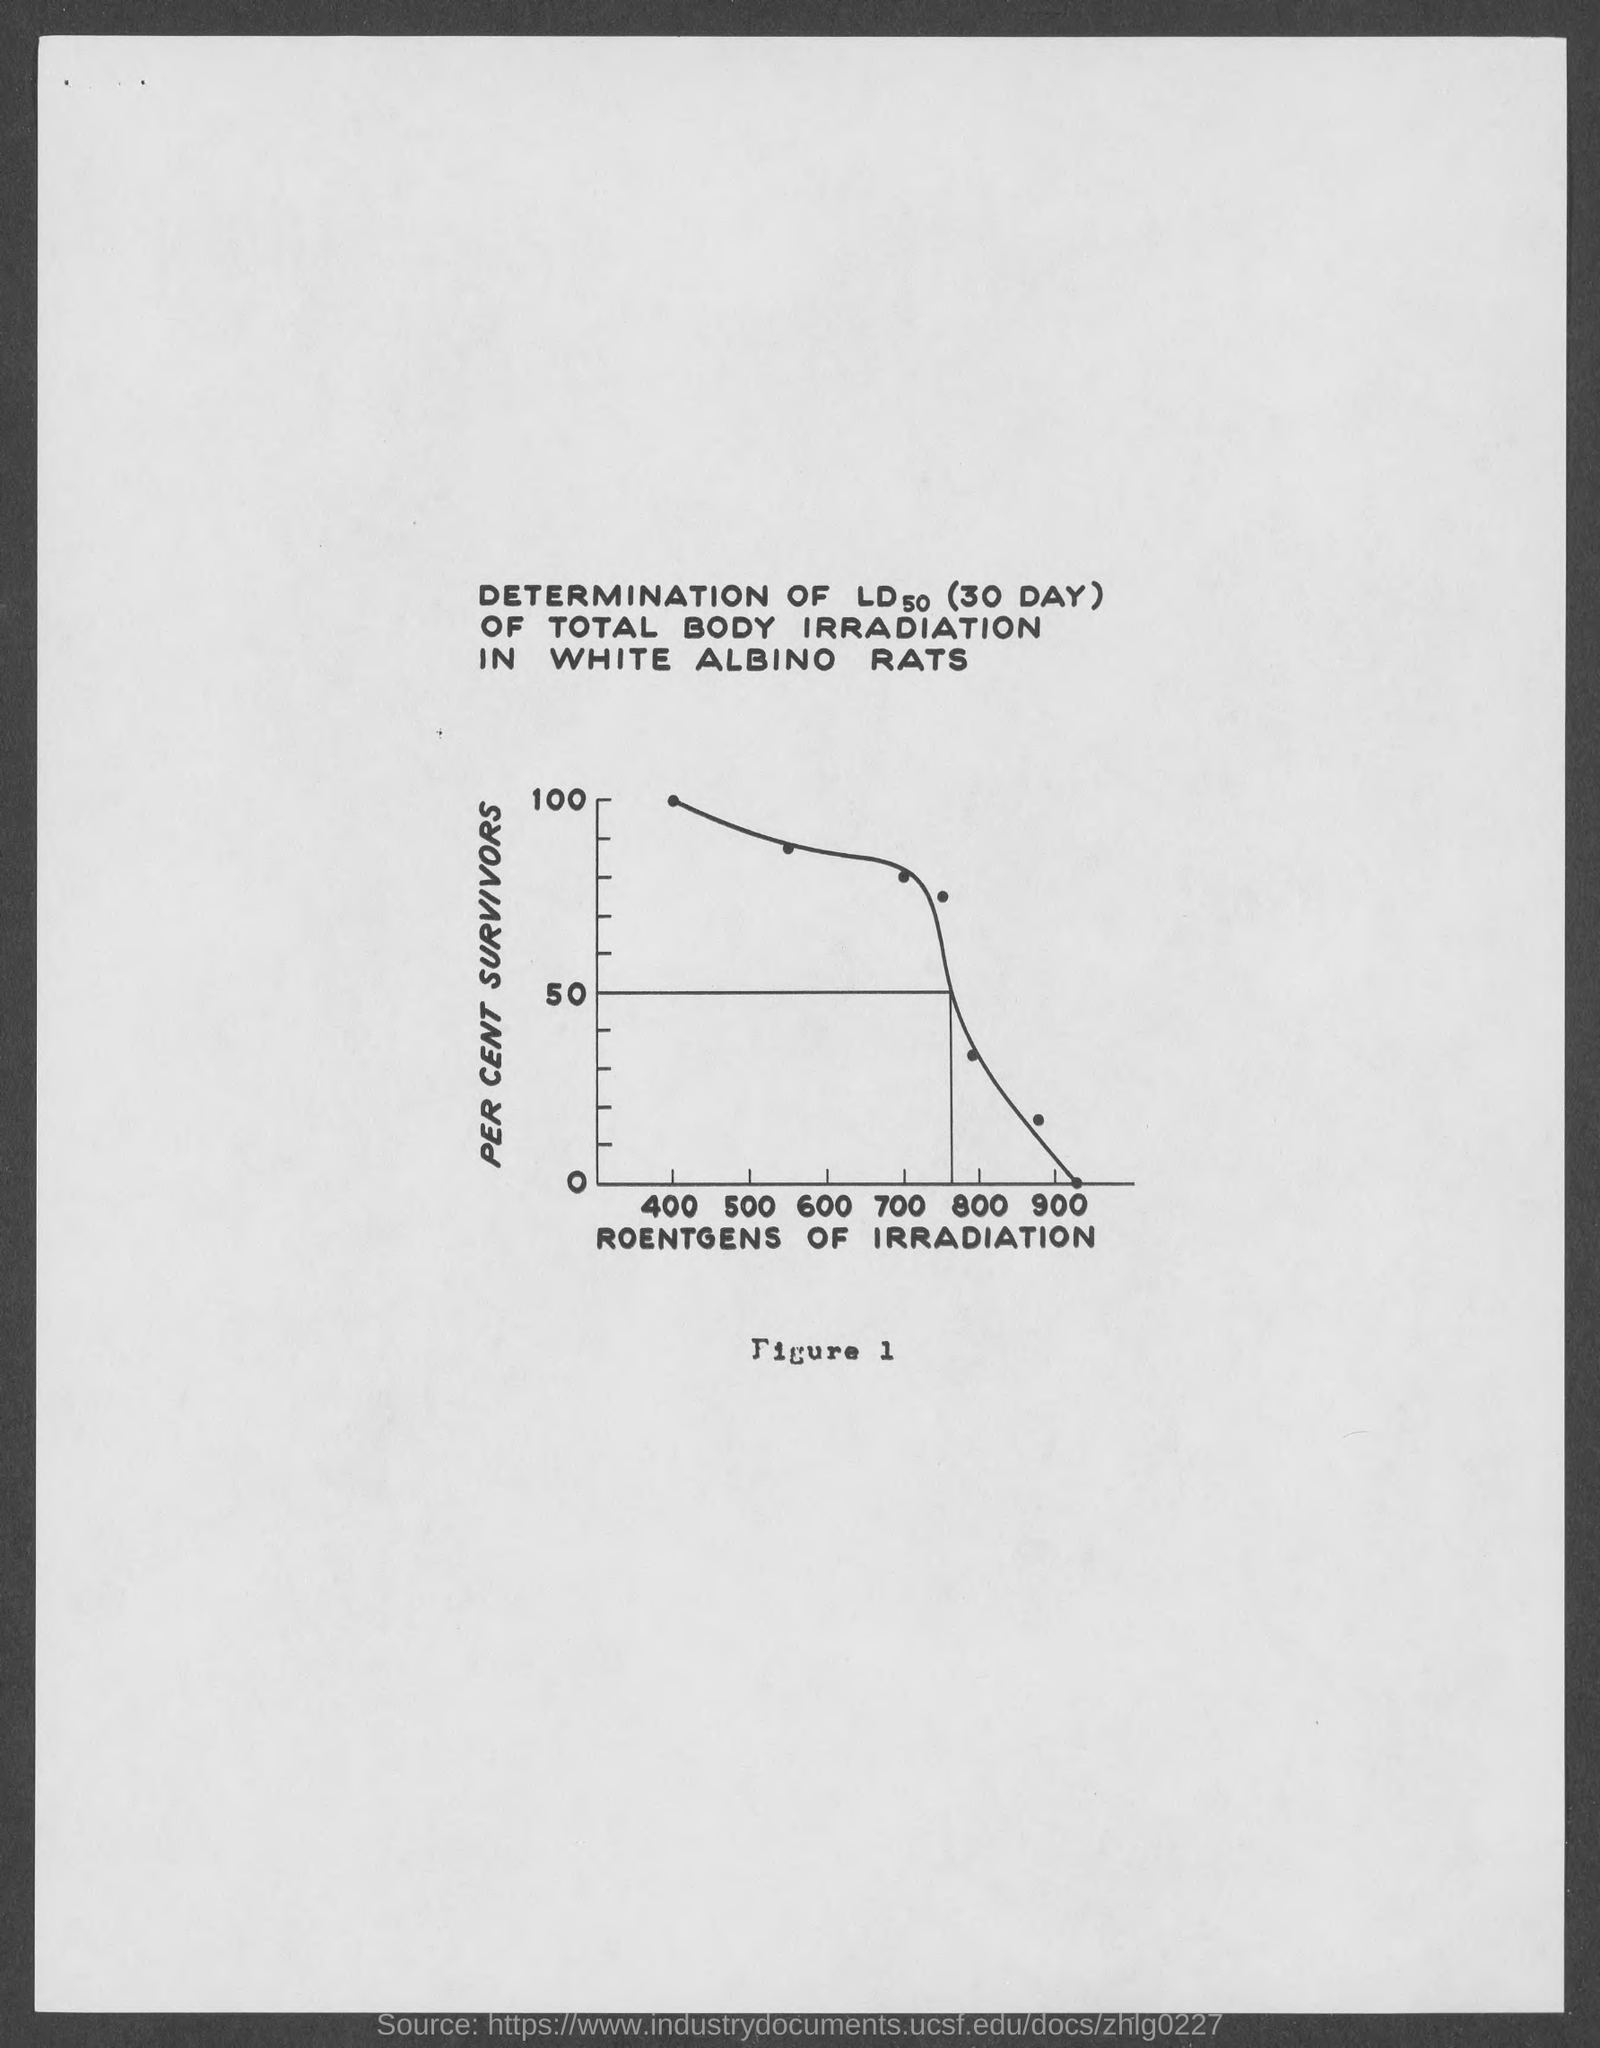What it indicates on X axis?
Ensure brevity in your answer.  Roentgens of irradiation. What it indicates on y axis ?
Your response must be concise. Per cent survivors. 